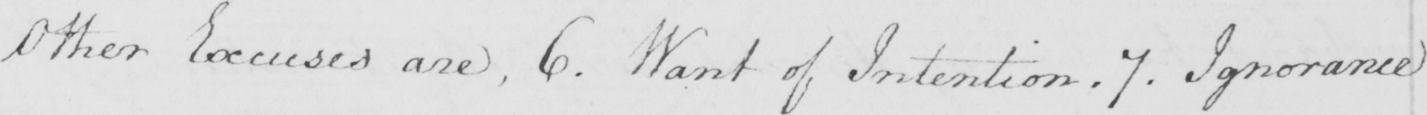Transcribe the text shown in this historical manuscript line. Other Excuses are  , 6 . Want of Intention . 7 . Ignorance 